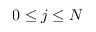<formula> <loc_0><loc_0><loc_500><loc_500>0 \leq j \leq N</formula> 